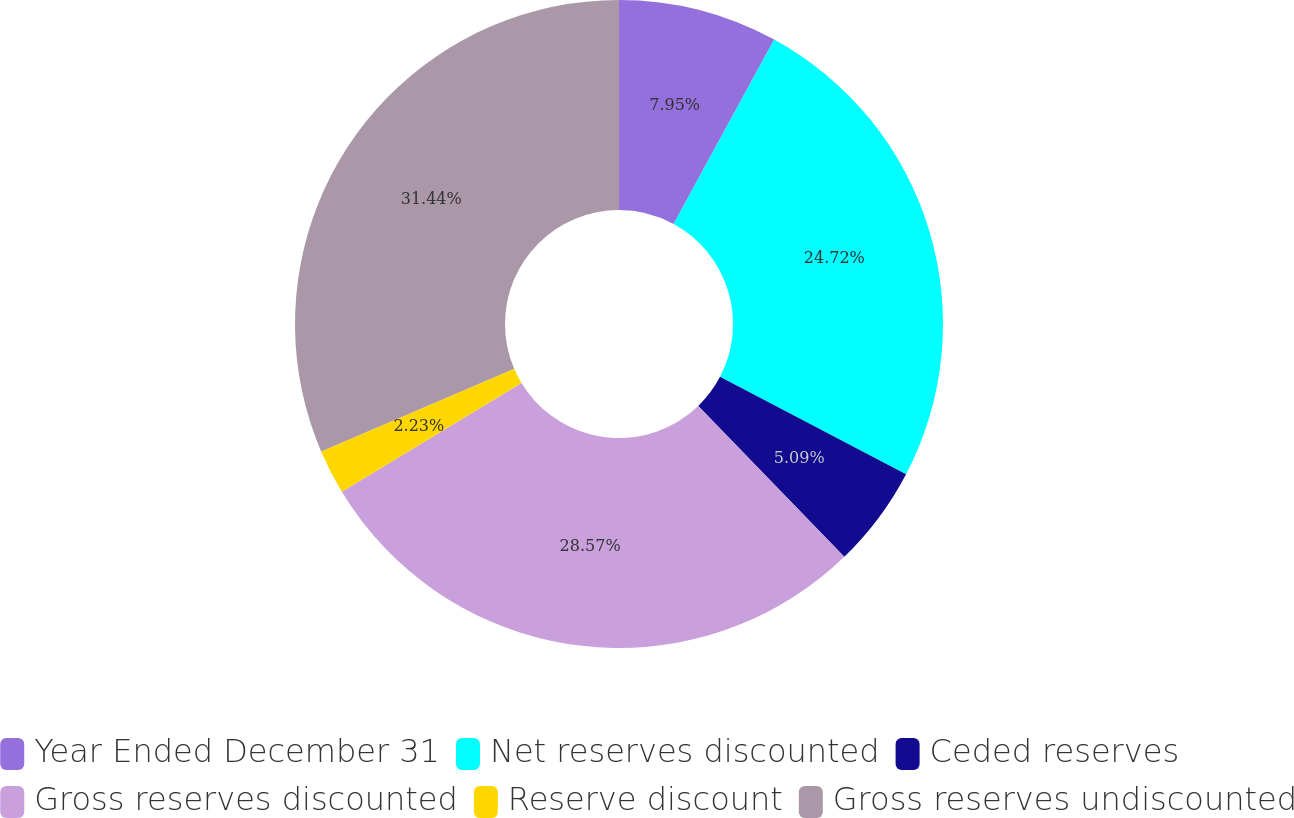<chart> <loc_0><loc_0><loc_500><loc_500><pie_chart><fcel>Year Ended December 31<fcel>Net reserves discounted<fcel>Ceded reserves<fcel>Gross reserves discounted<fcel>Reserve discount<fcel>Gross reserves undiscounted<nl><fcel>7.95%<fcel>24.72%<fcel>5.09%<fcel>28.57%<fcel>2.23%<fcel>31.43%<nl></chart> 